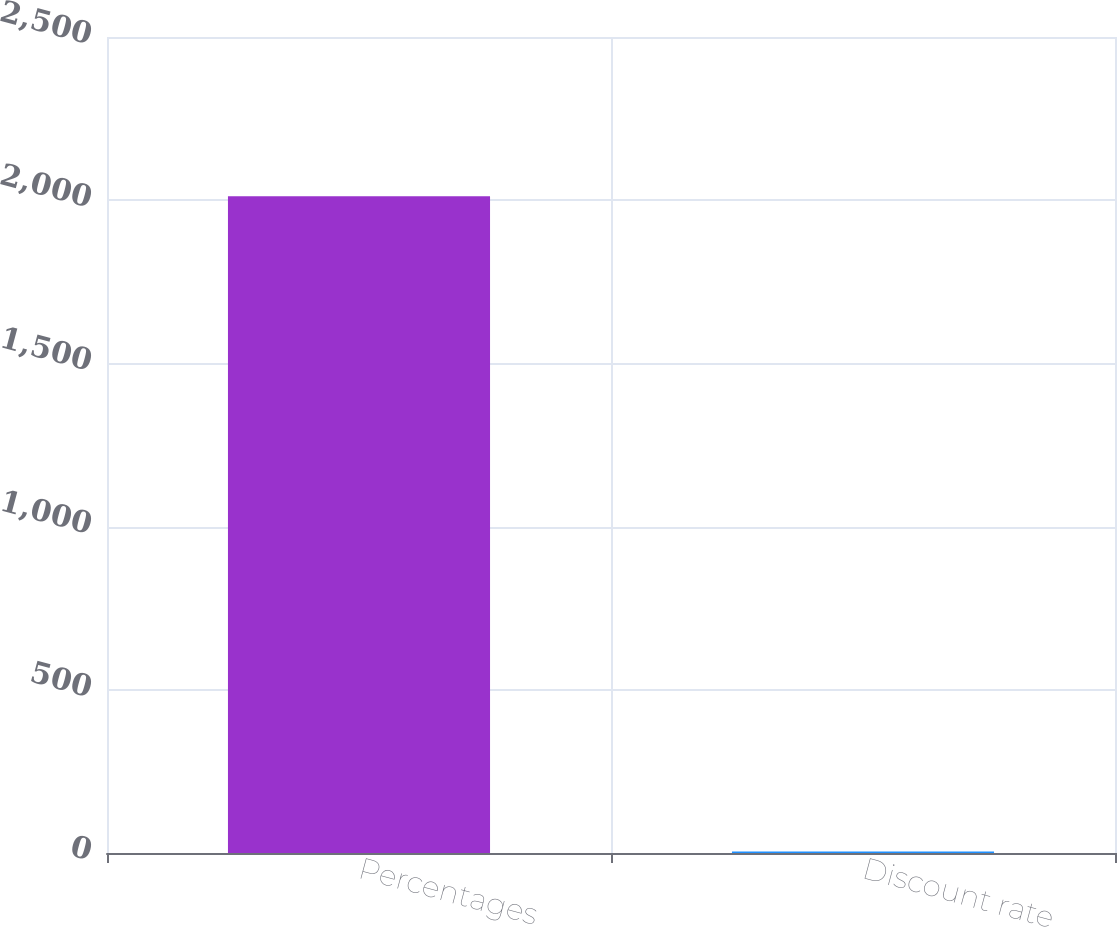Convert chart to OTSL. <chart><loc_0><loc_0><loc_500><loc_500><bar_chart><fcel>Percentages<fcel>Discount rate<nl><fcel>2012<fcel>4.36<nl></chart> 